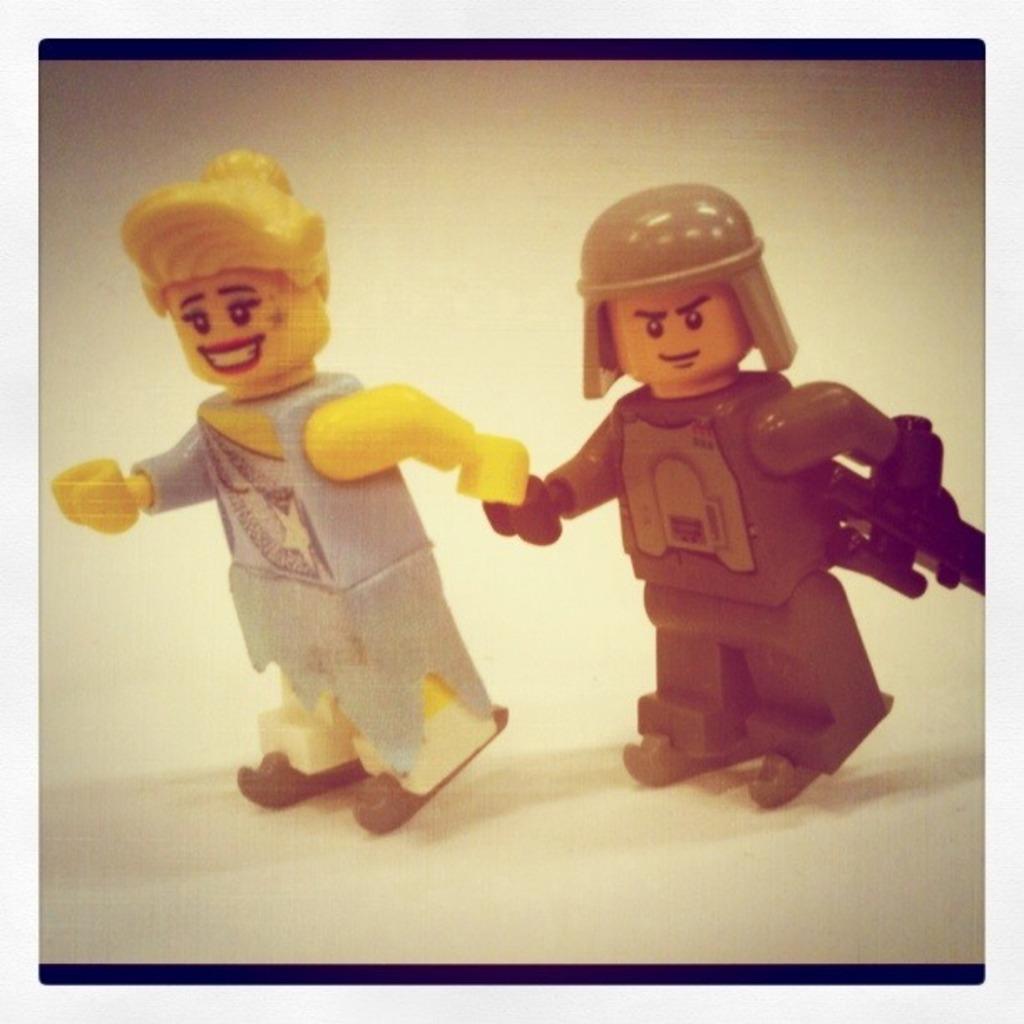In one or two sentences, can you explain what this image depicts? In this picture we can see two toys on a platform where a toy is smiling. 